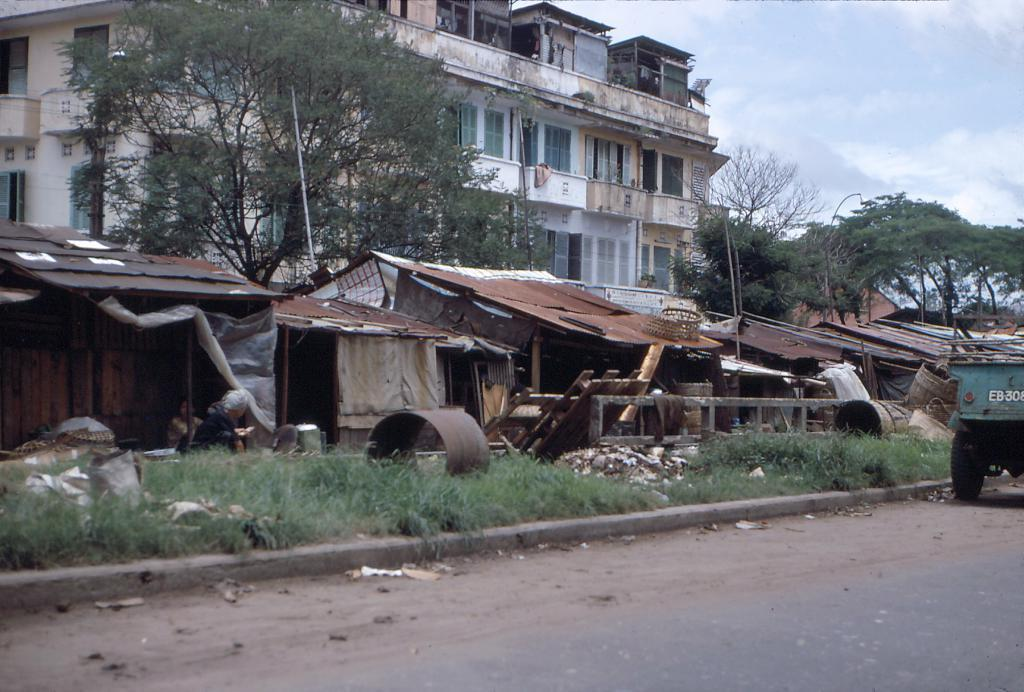What can be seen in the background of the image? There is a sky in the background of the image. What is located on the left side of the image? There is a building, trees, huts, grass, and other objects on the left side of the image. Can you describe the road in the image? There is a road in the image. How many bikes are parked on the grass in the image? There are no bikes present in the image. What type of pan is being used to cook over the huts in the image? There is no pan or cooking activity depicted in the image. 